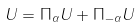Convert formula to latex. <formula><loc_0><loc_0><loc_500><loc_500>U = \Pi _ { \alpha } U + \Pi _ { - \alpha } U</formula> 